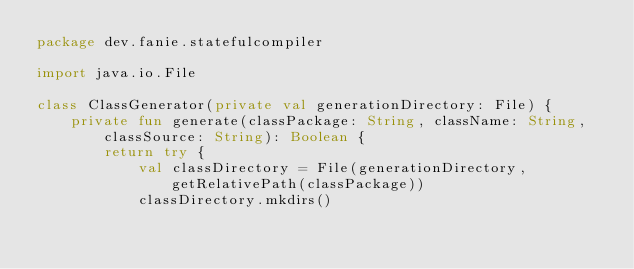Convert code to text. <code><loc_0><loc_0><loc_500><loc_500><_Kotlin_>package dev.fanie.statefulcompiler

import java.io.File

class ClassGenerator(private val generationDirectory: File) {
    private fun generate(classPackage: String, className: String, classSource: String): Boolean {
        return try {
            val classDirectory = File(generationDirectory, getRelativePath(classPackage))
            classDirectory.mkdirs()</code> 